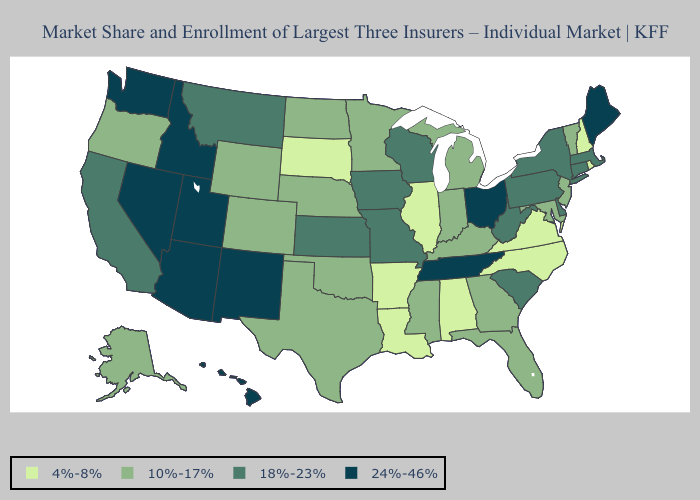Which states hav the highest value in the Northeast?
Write a very short answer. Maine. What is the highest value in the Northeast ?
Give a very brief answer. 24%-46%. Does Utah have a higher value than Idaho?
Short answer required. No. Does the map have missing data?
Be succinct. No. Does Ohio have the highest value in the MidWest?
Short answer required. Yes. Which states hav the highest value in the MidWest?
Be succinct. Ohio. Does Utah have the highest value in the West?
Quick response, please. Yes. Name the states that have a value in the range 18%-23%?
Give a very brief answer. California, Connecticut, Delaware, Iowa, Kansas, Massachusetts, Missouri, Montana, New York, Pennsylvania, South Carolina, West Virginia, Wisconsin. Among the states that border Wyoming , does South Dakota have the lowest value?
Quick response, please. Yes. What is the lowest value in states that border Michigan?
Answer briefly. 10%-17%. What is the highest value in states that border South Dakota?
Keep it brief. 18%-23%. Name the states that have a value in the range 10%-17%?
Give a very brief answer. Alaska, Colorado, Florida, Georgia, Indiana, Kentucky, Maryland, Michigan, Minnesota, Mississippi, Nebraska, New Jersey, North Dakota, Oklahoma, Oregon, Texas, Vermont, Wyoming. Name the states that have a value in the range 10%-17%?
Concise answer only. Alaska, Colorado, Florida, Georgia, Indiana, Kentucky, Maryland, Michigan, Minnesota, Mississippi, Nebraska, New Jersey, North Dakota, Oklahoma, Oregon, Texas, Vermont, Wyoming. What is the highest value in the USA?
Answer briefly. 24%-46%. Name the states that have a value in the range 10%-17%?
Give a very brief answer. Alaska, Colorado, Florida, Georgia, Indiana, Kentucky, Maryland, Michigan, Minnesota, Mississippi, Nebraska, New Jersey, North Dakota, Oklahoma, Oregon, Texas, Vermont, Wyoming. 